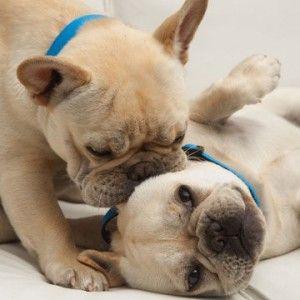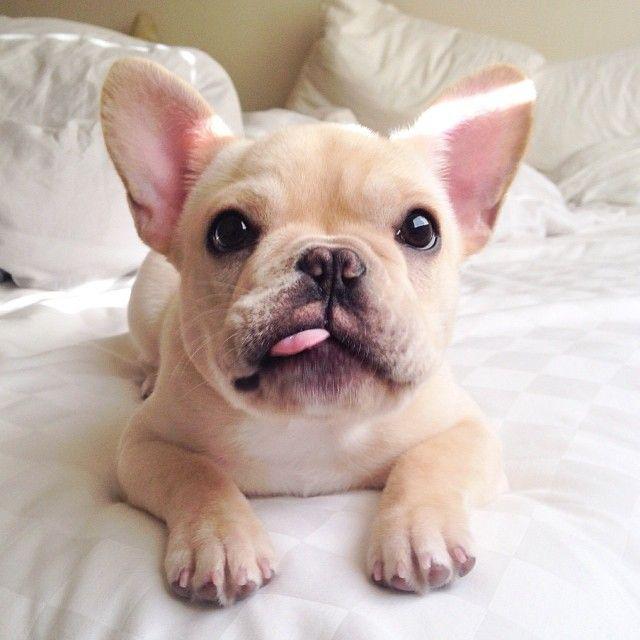The first image is the image on the left, the second image is the image on the right. For the images shown, is this caption "Left image shows side-by-side dogs, with at least one dog sitting upright." true? Answer yes or no. No. The first image is the image on the left, the second image is the image on the right. Given the left and right images, does the statement "In one image, two dogs are touching one another, with at least one of the dogs touching the other with its mouth" hold true? Answer yes or no. Yes. 